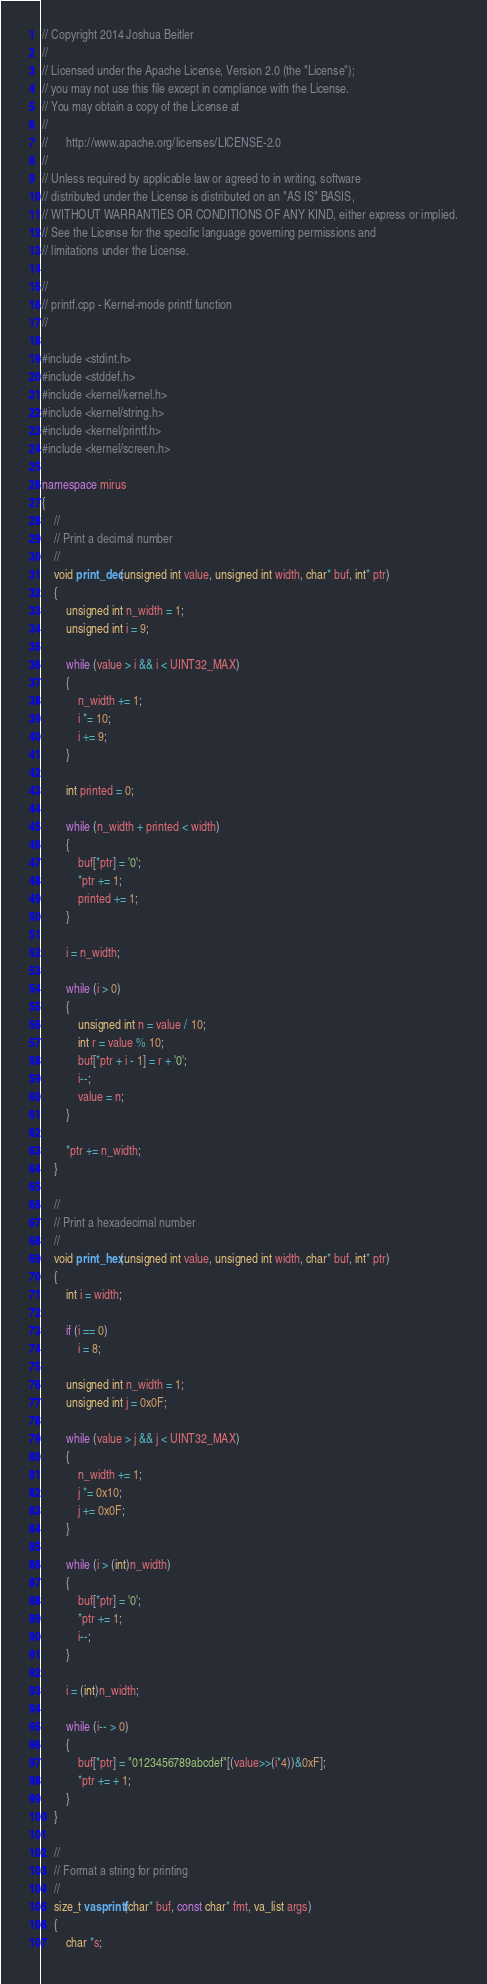Convert code to text. <code><loc_0><loc_0><loc_500><loc_500><_C++_>// Copyright 2014 Joshua Beitler
//
// Licensed under the Apache License, Version 2.0 (the "License");
// you may not use this file except in compliance with the License.
// You may obtain a copy of the License at
//
//      http://www.apache.org/licenses/LICENSE-2.0
//
// Unless required by applicable law or agreed to in writing, software
// distributed under the License is distributed on an "AS IS" BASIS,
// WITHOUT WARRANTIES OR CONDITIONS OF ANY KIND, either express or implied.
// See the License for the specific language governing permissions and
// limitations under the License.

//
// printf.cpp - Kernel-mode printf function
//

#include <stdint.h>
#include <stddef.h>
#include <kernel/kernel.h>
#include <kernel/string.h>
#include <kernel/printf.h>
#include <kernel/screen.h>

namespace mirus
{
    //
    // Print a decimal number
    //
    void print_dec(unsigned int value, unsigned int width, char* buf, int* ptr) 
    {
        unsigned int n_width = 1;
        unsigned int i = 9;
        
        while (value > i && i < UINT32_MAX)
        {
            n_width += 1;
            i *= 10;
            i += 9;
        }

        int printed = 0;
        
        while (n_width + printed < width) 
        {
            buf[*ptr] = '0';
            *ptr += 1;
            printed += 1;
        }

        i = n_width;
        
        while (i > 0)
        {
            unsigned int n = value / 10;
            int r = value % 10;
            buf[*ptr + i - 1] = r + '0';
            i--;
            value = n;
        }

        *ptr += n_width;
    }

    //
    // Print a hexadecimal number
    //
    void print_hex(unsigned int value, unsigned int width, char* buf, int* ptr) 
    {
        int i = width;

        if (i == 0) 
            i = 8;

        unsigned int n_width = 1;
        unsigned int j = 0x0F;
        
        while (value > j && j < UINT32_MAX) 
        {
            n_width += 1;
            j *= 0x10;
            j += 0x0F;
        }

        while (i > (int)n_width) 
        {
            buf[*ptr] = '0';
            *ptr += 1;
            i--;
        }

        i = (int)n_width;
        
        while (i-- > 0) 
        {
            buf[*ptr] = "0123456789abcdef"[(value>>(i*4))&0xF];
            *ptr += + 1;
        }
    }

    //
    // Format a string for printing
    //
    size_t vasprintf(char* buf, const char* fmt, va_list args) 
    {
        char *s;</code> 